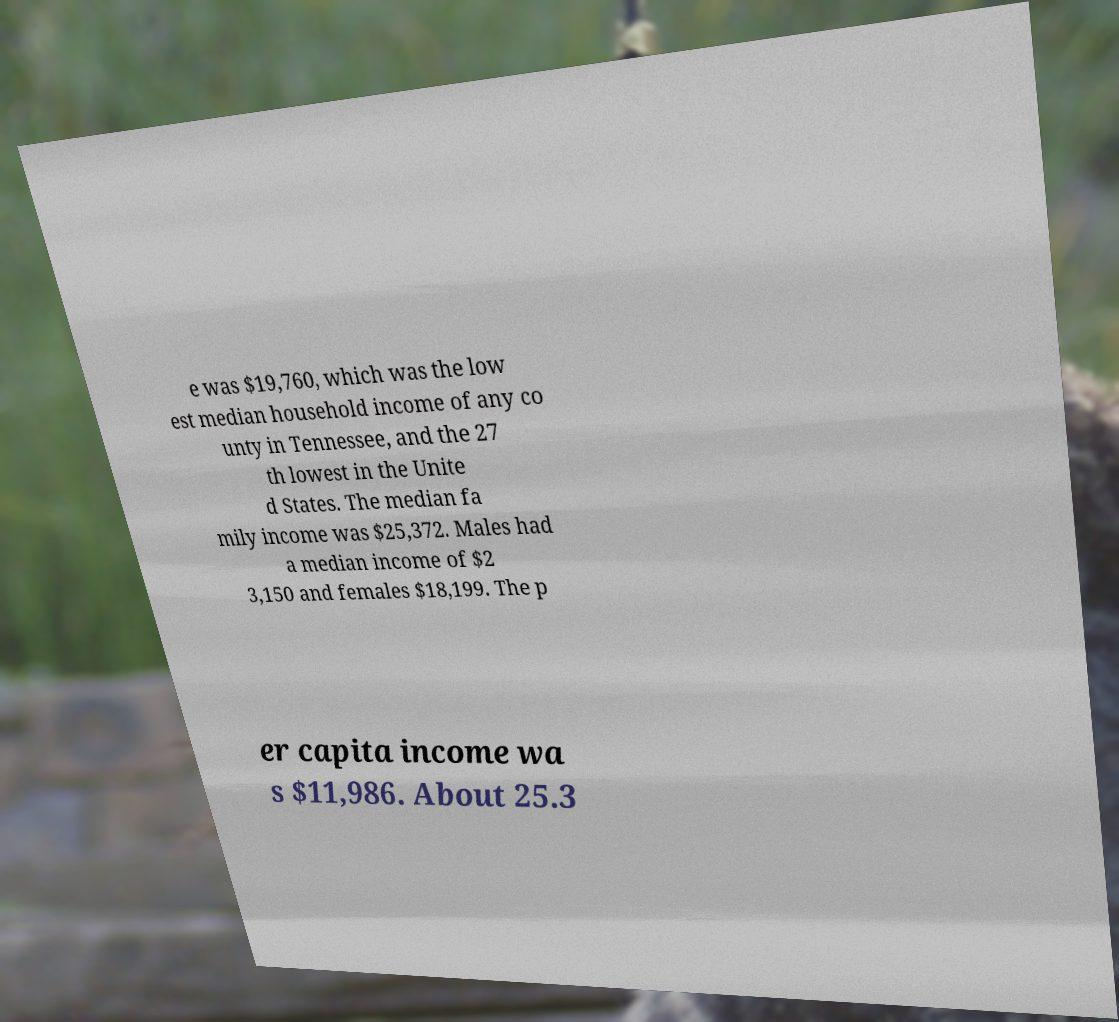Could you assist in decoding the text presented in this image and type it out clearly? e was $19,760, which was the low est median household income of any co unty in Tennessee, and the 27 th lowest in the Unite d States. The median fa mily income was $25,372. Males had a median income of $2 3,150 and females $18,199. The p er capita income wa s $11,986. About 25.3 